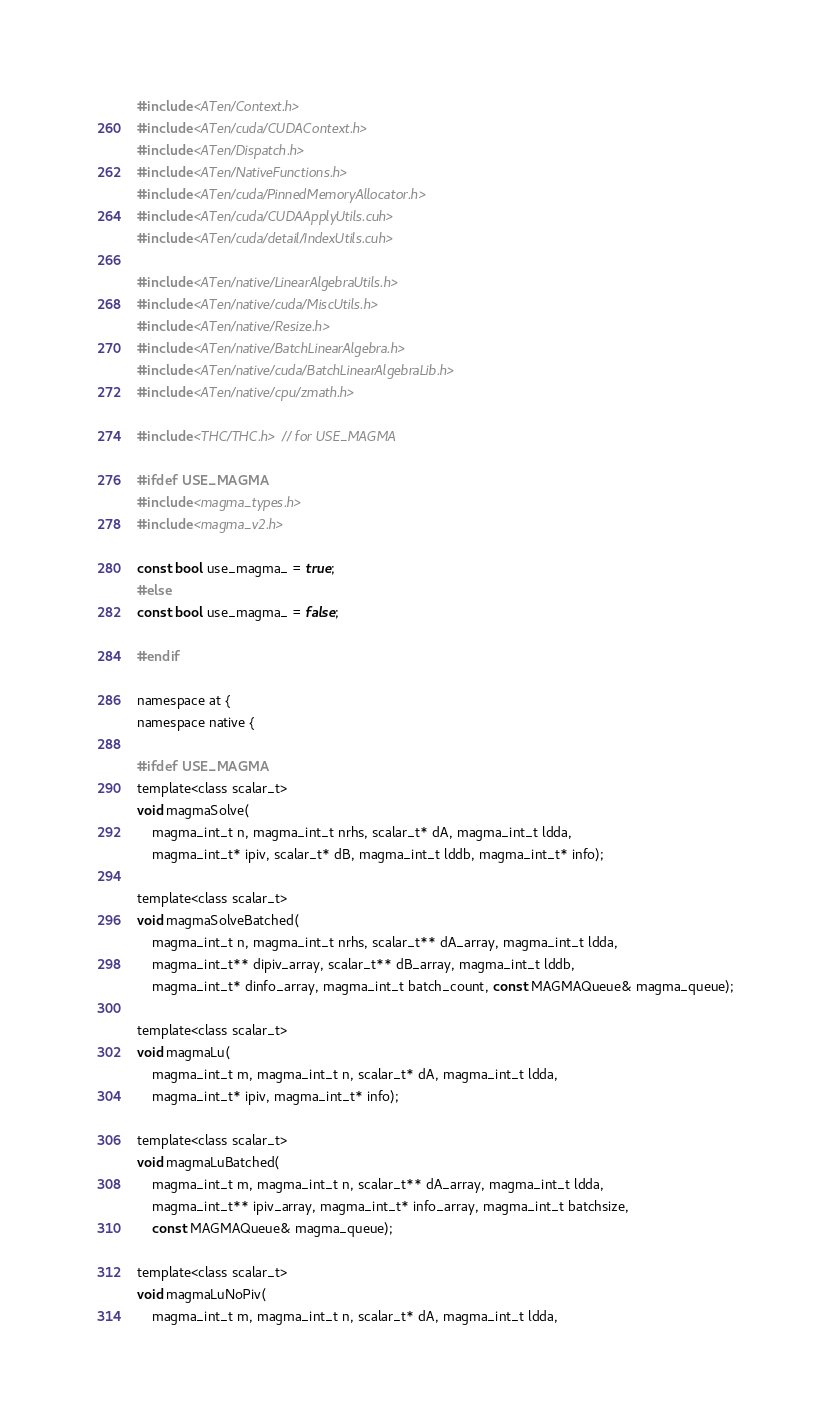Convert code to text. <code><loc_0><loc_0><loc_500><loc_500><_Cuda_>#include <ATen/Context.h>
#include <ATen/cuda/CUDAContext.h>
#include <ATen/Dispatch.h>
#include <ATen/NativeFunctions.h>
#include <ATen/cuda/PinnedMemoryAllocator.h>
#include <ATen/cuda/CUDAApplyUtils.cuh>
#include <ATen/cuda/detail/IndexUtils.cuh>

#include <ATen/native/LinearAlgebraUtils.h>
#include <ATen/native/cuda/MiscUtils.h>
#include <ATen/native/Resize.h>
#include <ATen/native/BatchLinearAlgebra.h>
#include <ATen/native/cuda/BatchLinearAlgebraLib.h>
#include <ATen/native/cpu/zmath.h>

#include <THC/THC.h> // for USE_MAGMA

#ifdef USE_MAGMA
#include <magma_types.h>
#include <magma_v2.h>

const bool use_magma_ = true;
#else
const bool use_magma_ = false;

#endif

namespace at {
namespace native {

#ifdef USE_MAGMA
template<class scalar_t>
void magmaSolve(
    magma_int_t n, magma_int_t nrhs, scalar_t* dA, magma_int_t ldda,
    magma_int_t* ipiv, scalar_t* dB, magma_int_t lddb, magma_int_t* info);

template<class scalar_t>
void magmaSolveBatched(
    magma_int_t n, magma_int_t nrhs, scalar_t** dA_array, magma_int_t ldda,
    magma_int_t** dipiv_array, scalar_t** dB_array, magma_int_t lddb,
    magma_int_t* dinfo_array, magma_int_t batch_count, const MAGMAQueue& magma_queue);

template<class scalar_t>
void magmaLu(
    magma_int_t m, magma_int_t n, scalar_t* dA, magma_int_t ldda,
    magma_int_t* ipiv, magma_int_t* info);

template<class scalar_t>
void magmaLuBatched(
    magma_int_t m, magma_int_t n, scalar_t** dA_array, magma_int_t ldda,
    magma_int_t** ipiv_array, magma_int_t* info_array, magma_int_t batchsize,
    const MAGMAQueue& magma_queue);

template<class scalar_t>
void magmaLuNoPiv(
    magma_int_t m, magma_int_t n, scalar_t* dA, magma_int_t ldda,</code> 